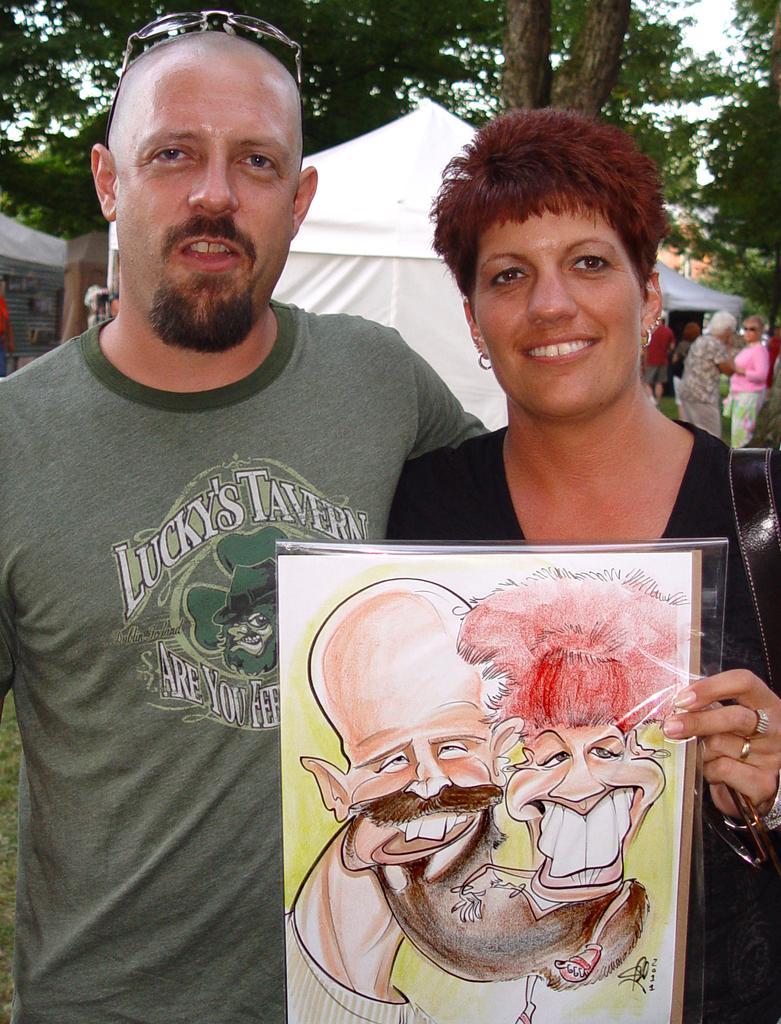Could you give a brief overview of what you see in this image? This picture is clicked outside. In the foreground we can see the pictures of the two persons on a poster and we can see a person smiling, standing, holding some items and we can see a man wearing t-shirt and seems to be standing. In the background we can see the sky, trees, tents, group of people and some other objects. 